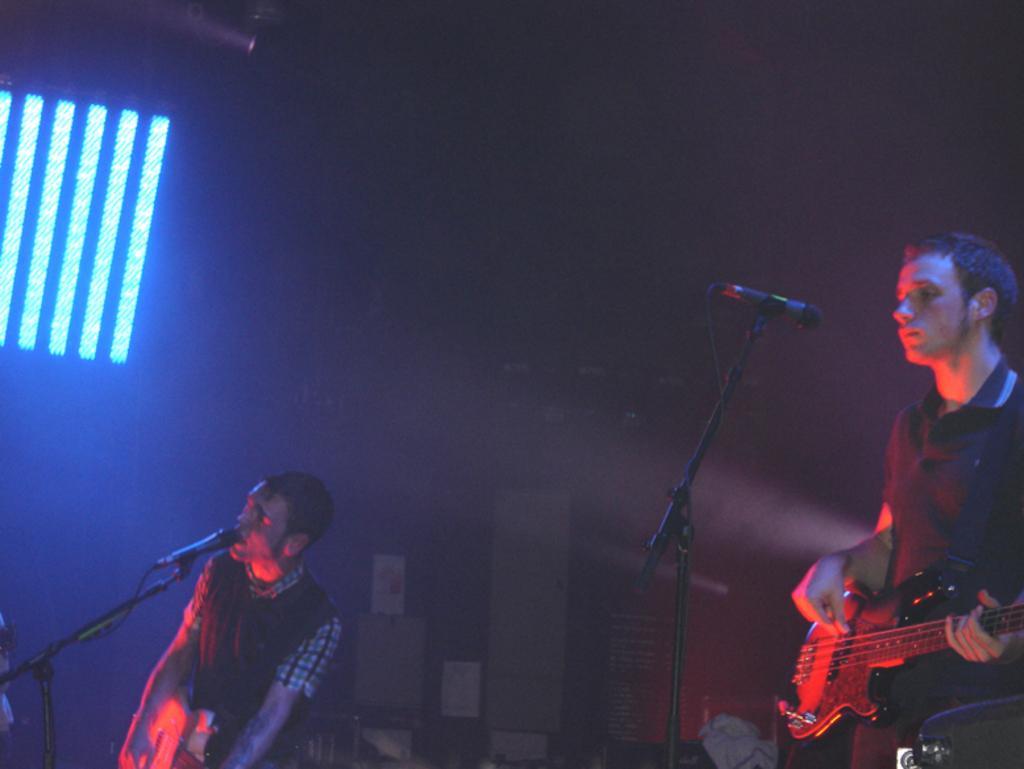In one or two sentences, can you explain what this image depicts? a person is standing black t shirt and playing guitar. in front of him there is a microphone. at the left a person is playing guitar wearing a black t shirt and singing. there is a microphone in front of him. at the back there is a black background and at the left there are blue lights. 